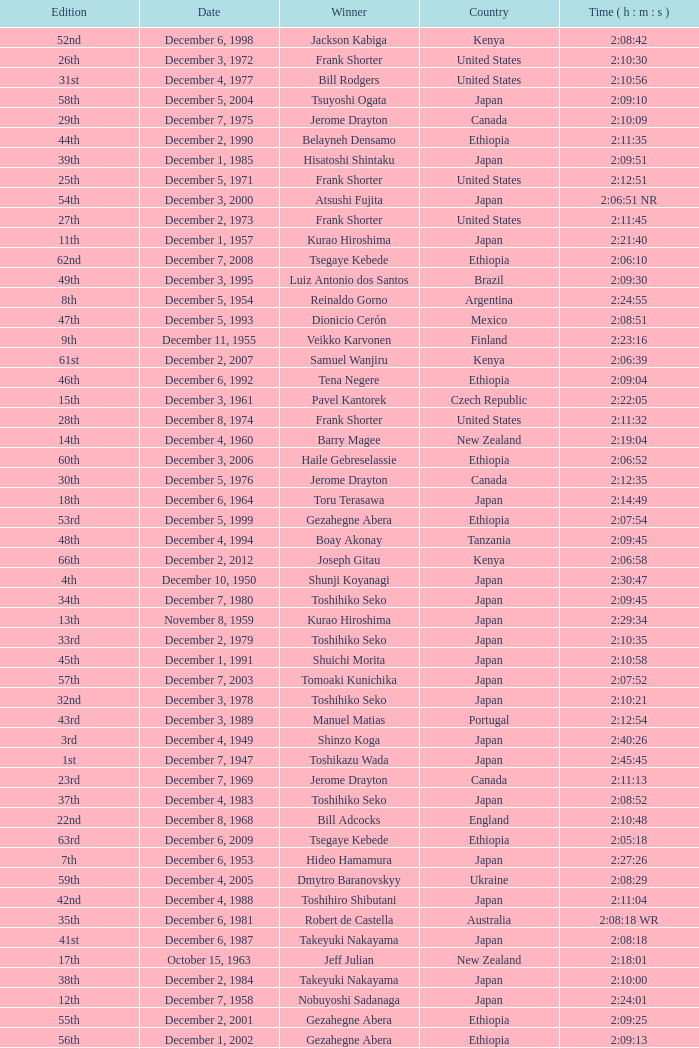What was the nationality of the winner for the 20th Edition? New Zealand. 